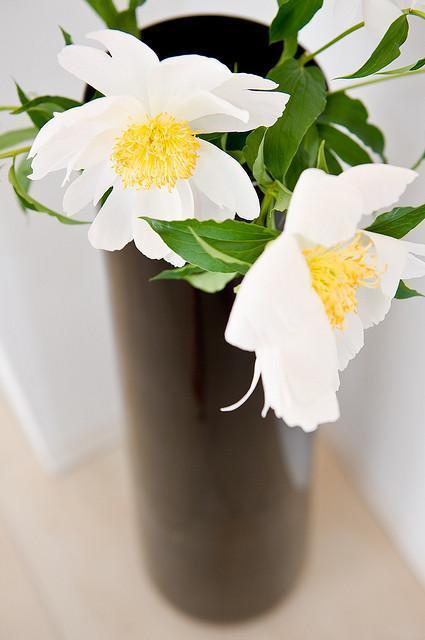How many vases are there?
Give a very brief answer. 2. How many people are wearing a jacket?
Give a very brief answer. 0. 